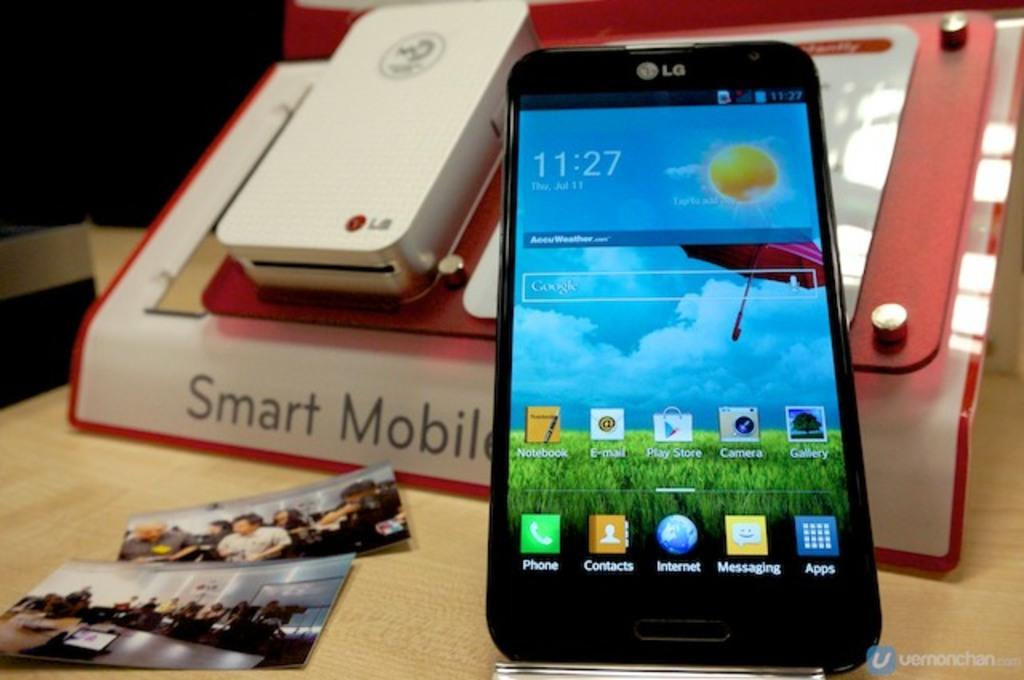<image>
Describe the image concisely. lg phone showing time of 11:27 next to display mode of lg mobile photo printer 